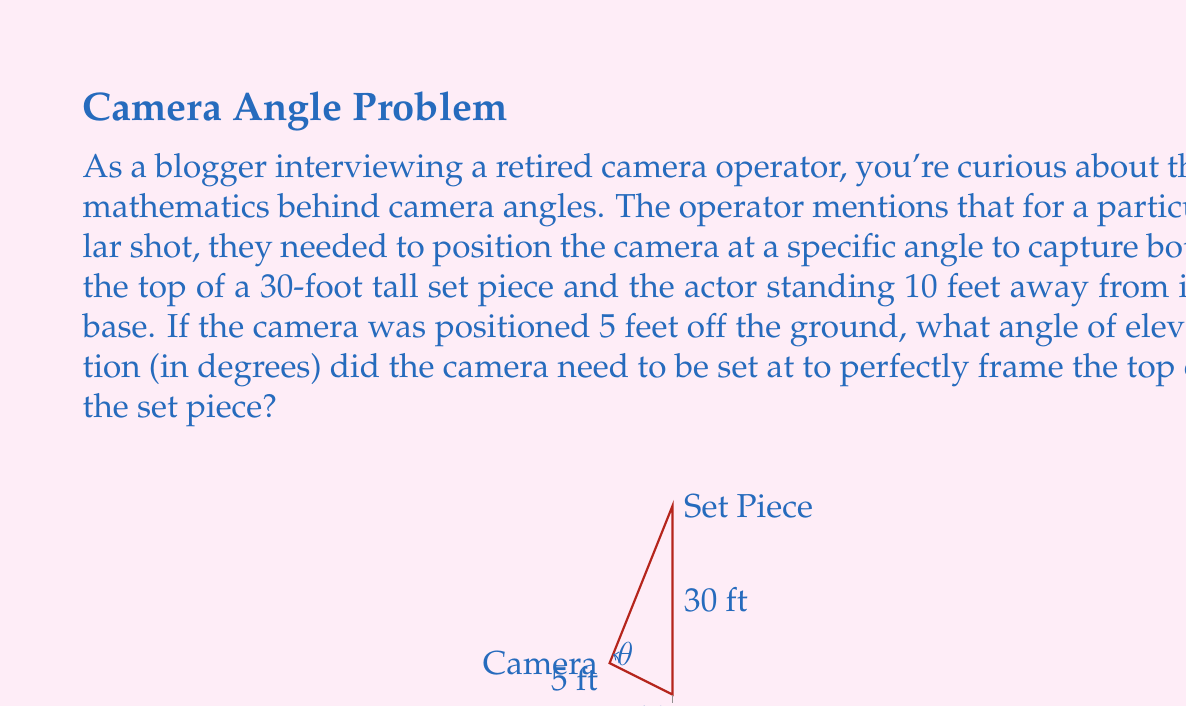Solve this math problem. To solve this problem, we'll use trigonometry, specifically the tangent function. Let's break it down step-by-step:

1) First, let's visualize the scenario. We have a right triangle where:
   - The camera is at the base of the triangle, 5 feet off the ground
   - The horizontal distance to the set piece is 10 feet
   - The total height we need to capture is 30 feet

2) We need to find the angle of elevation ($\theta$) from the camera to the top of the set piece.

3) In this right triangle:
   - The adjacent side is the horizontal distance: 10 feet
   - The opposite side is the difference between the total height and the camera height: 30 - 5 = 25 feet

4) We can use the tangent function, which is defined as:

   $$ \tan(\theta) = \frac{\text{opposite}}{\text{adjacent}} $$

5) Plugging in our values:

   $$ \tan(\theta) = \frac{25}{10} = 2.5 $$

6) To find $\theta$, we need to use the inverse tangent (arctan or $\tan^{-1}$):

   $$ \theta = \tan^{-1}(2.5) $$

7) Using a calculator or computer:

   $$ \theta \approx 68.1986... \text{ degrees} $$

8) Rounding to two decimal places:

   $$ \theta \approx 68.20\text{ degrees} $$
Answer: The camera needs to be set at an angle of elevation of approximately 68.20 degrees. 